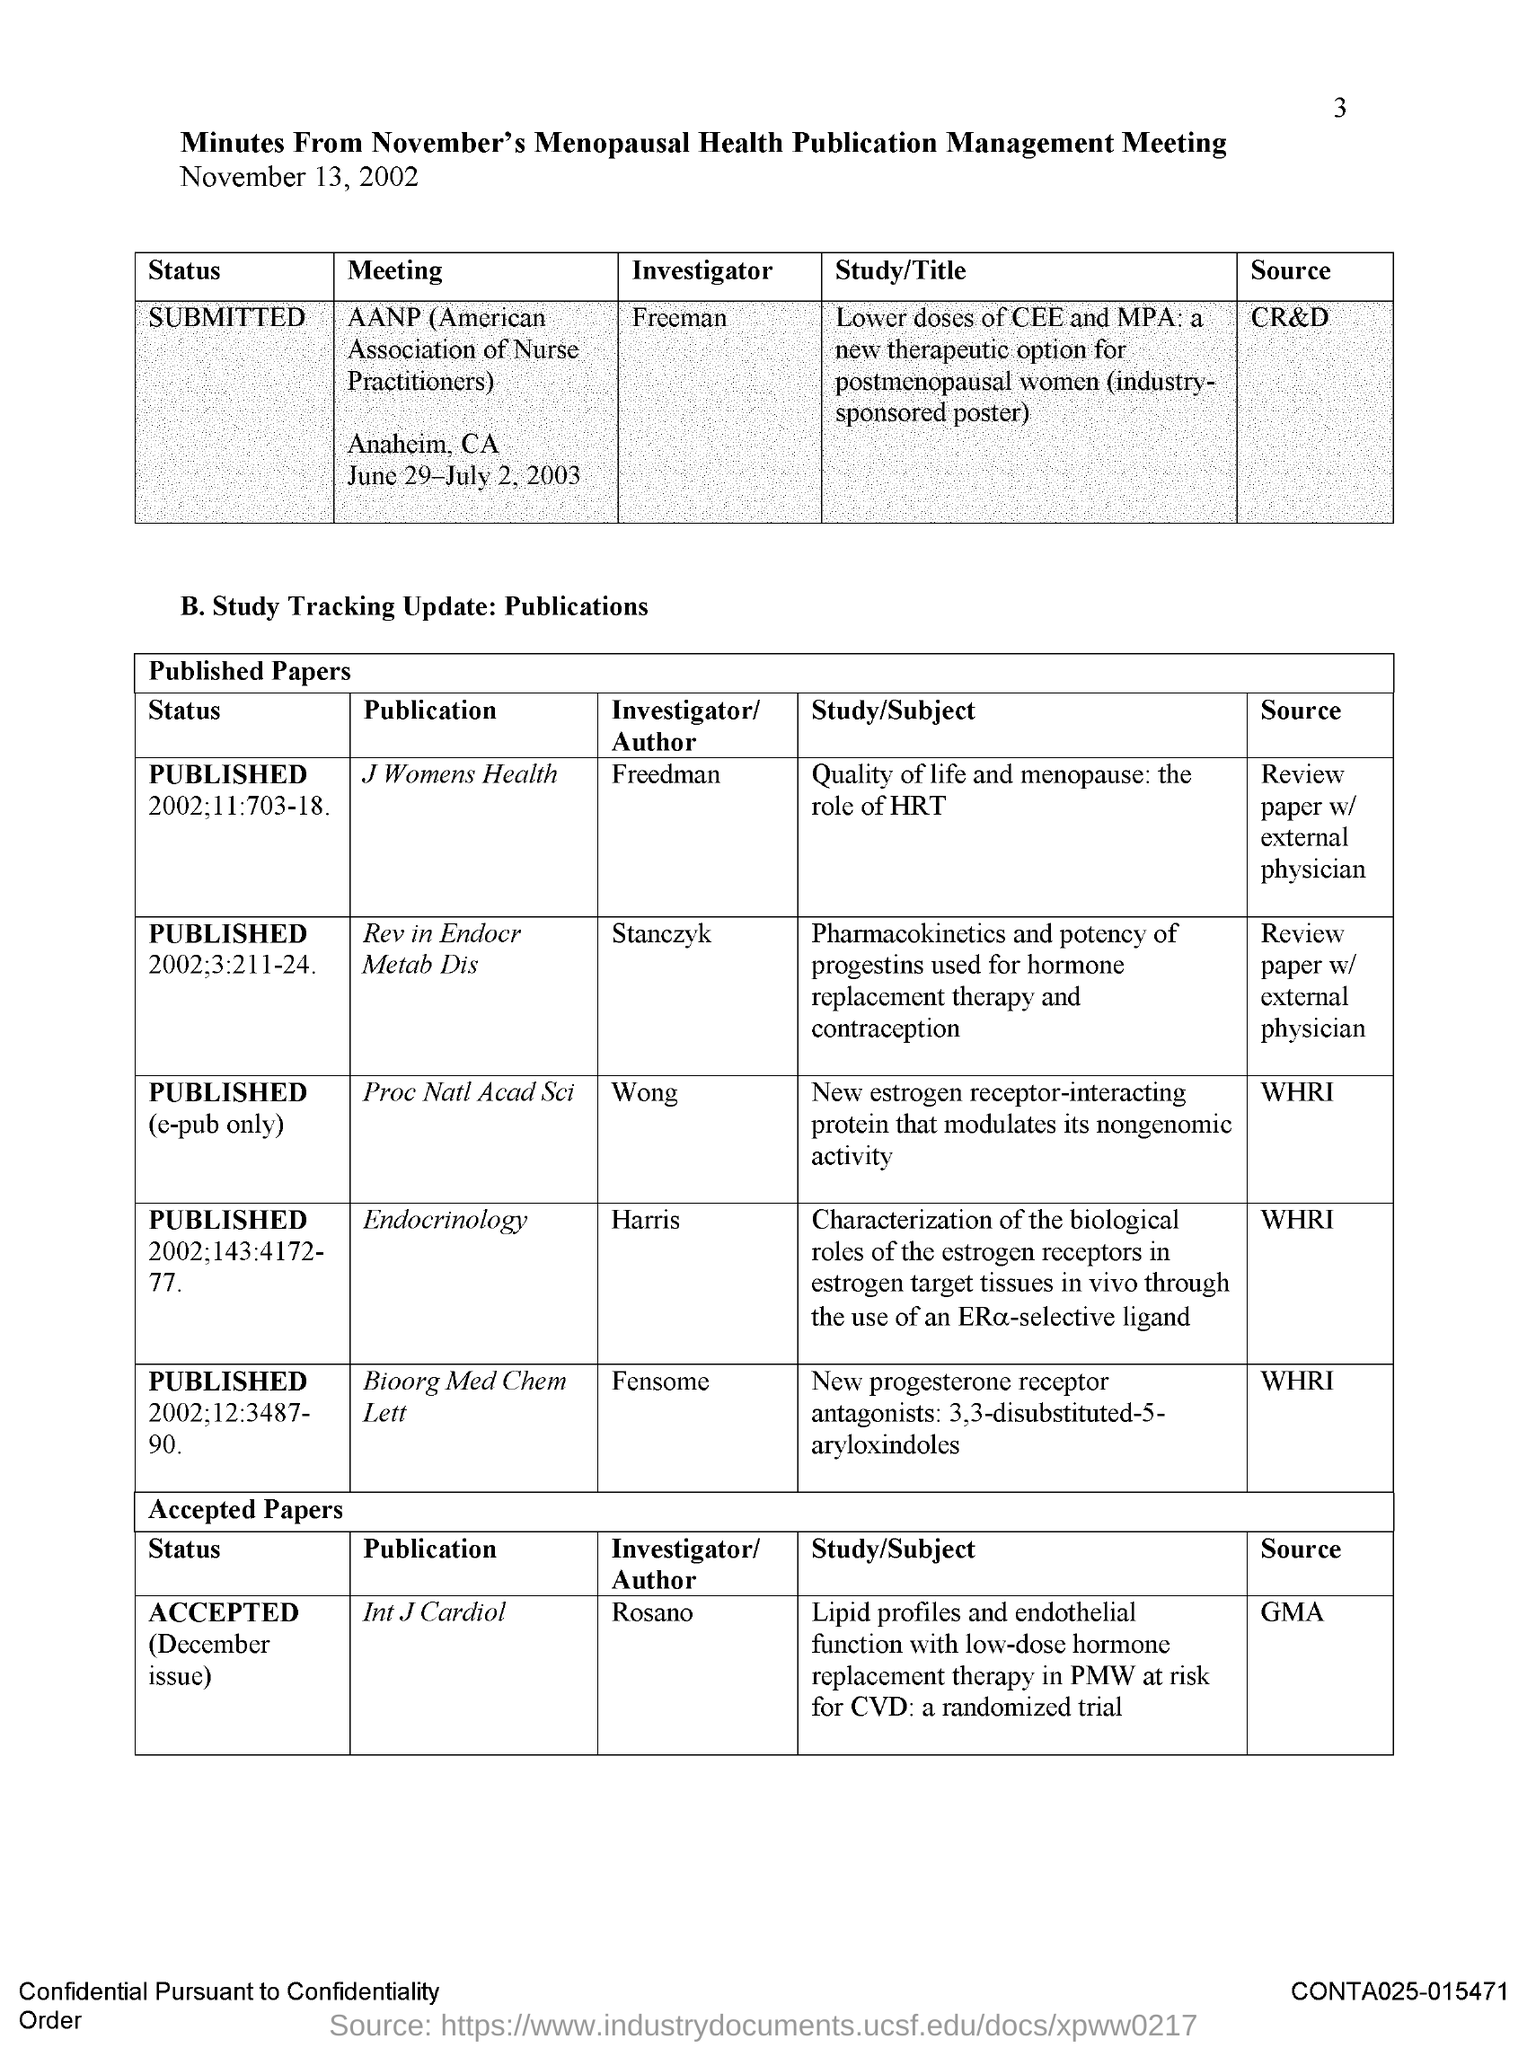Indicate a few pertinent items in this graphic. The source for publication of the journal "Endocrinology" is the WHRI. The investigator for the publication 'Proc Nat Acad Sci' is WONG. The source for the AANP meeting is CR&D. The source of publication for the journal "International Journal of Cardiology" is the Global Medical Association (GMA). The source for publication of the "Proc Nat Acad Sci" is the WHRI (Western Highlands Research Institute). 